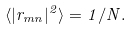Convert formula to latex. <formula><loc_0><loc_0><loc_500><loc_500>\langle | r _ { m n } | ^ { 2 } \rangle = 1 / N .</formula> 